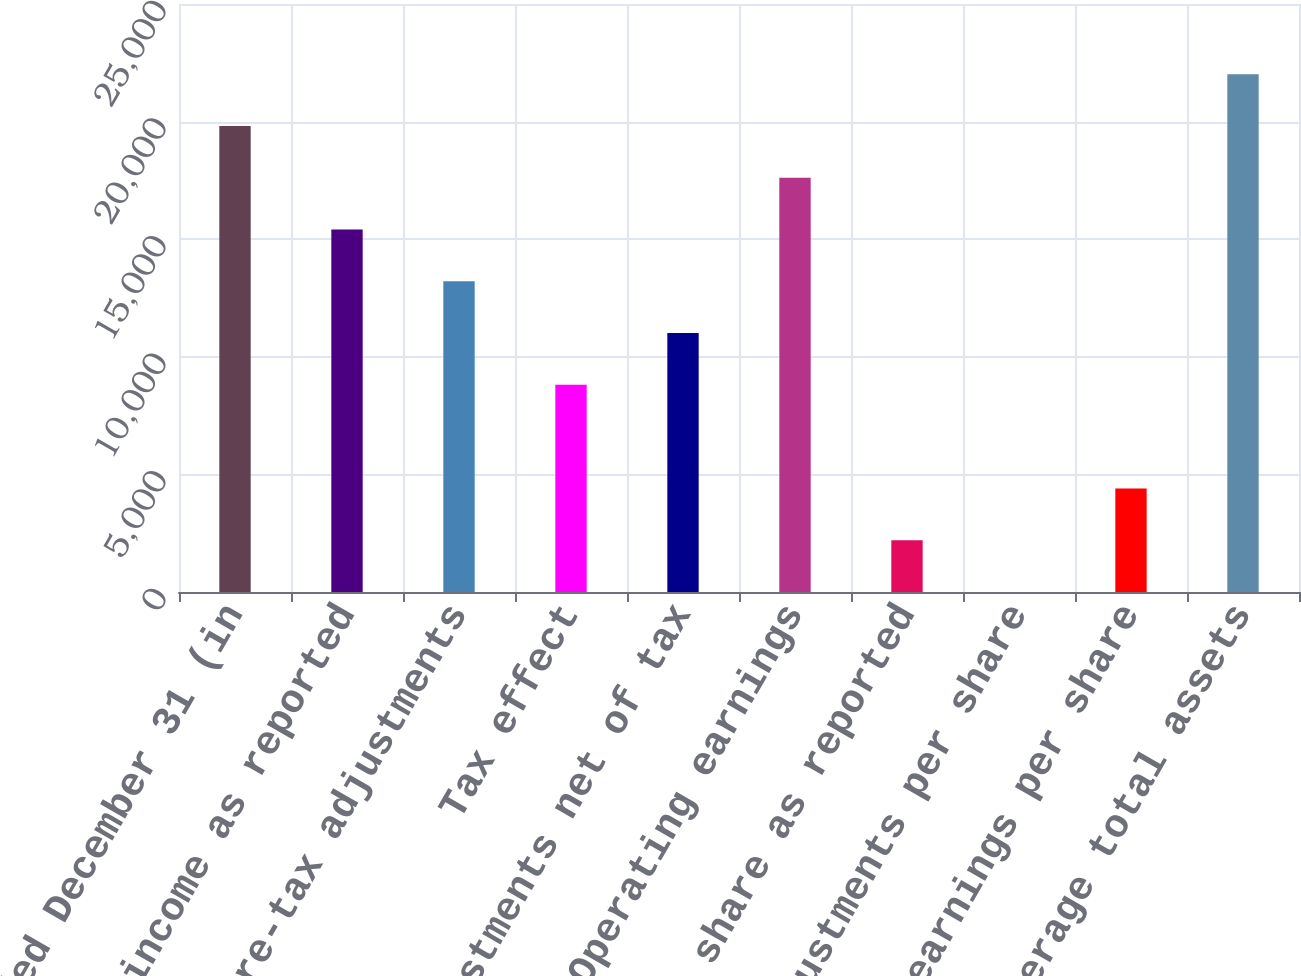<chart> <loc_0><loc_0><loc_500><loc_500><bar_chart><fcel>Years ended December 31 (in<fcel>Net income as reported<fcel>Total pre-tax adjustments<fcel>Tax effect<fcel>Total adjustments net of tax<fcel>Operating earnings<fcel>Earnings per share as reported<fcel>Total adjustments per share<fcel>Operating earnings per share<fcel>Average total assets<nl><fcel>19814.4<fcel>15411.2<fcel>13209.6<fcel>8806.47<fcel>11008.1<fcel>17612.8<fcel>2201.7<fcel>0.11<fcel>4403.29<fcel>22016<nl></chart> 